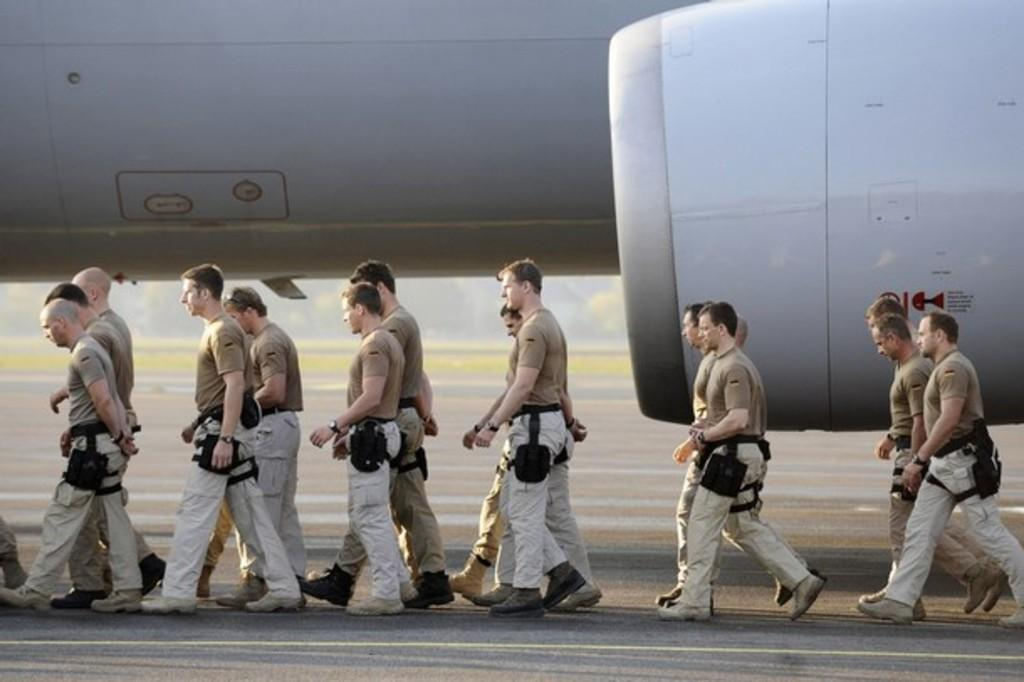What are the people in the image doing? The people in the image are walking. What can be seen in the background of the image? There is a white color aircraft in the background of the image. What type of unit is being used to measure the distance between the people in the image? There is no unit mentioned or visible in the image, so it cannot be determined what type of unit is being used. 